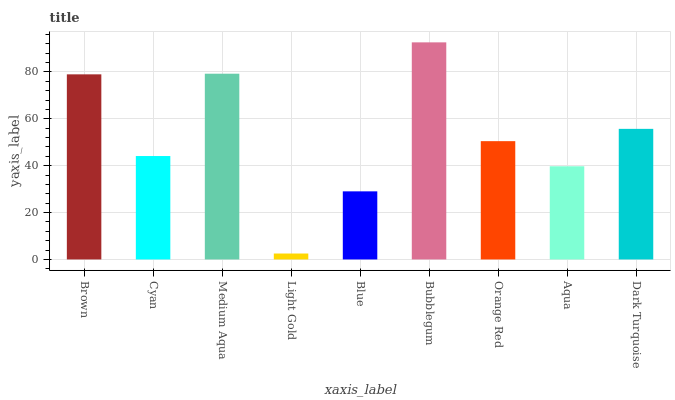Is Cyan the minimum?
Answer yes or no. No. Is Cyan the maximum?
Answer yes or no. No. Is Brown greater than Cyan?
Answer yes or no. Yes. Is Cyan less than Brown?
Answer yes or no. Yes. Is Cyan greater than Brown?
Answer yes or no. No. Is Brown less than Cyan?
Answer yes or no. No. Is Orange Red the high median?
Answer yes or no. Yes. Is Orange Red the low median?
Answer yes or no. Yes. Is Aqua the high median?
Answer yes or no. No. Is Dark Turquoise the low median?
Answer yes or no. No. 